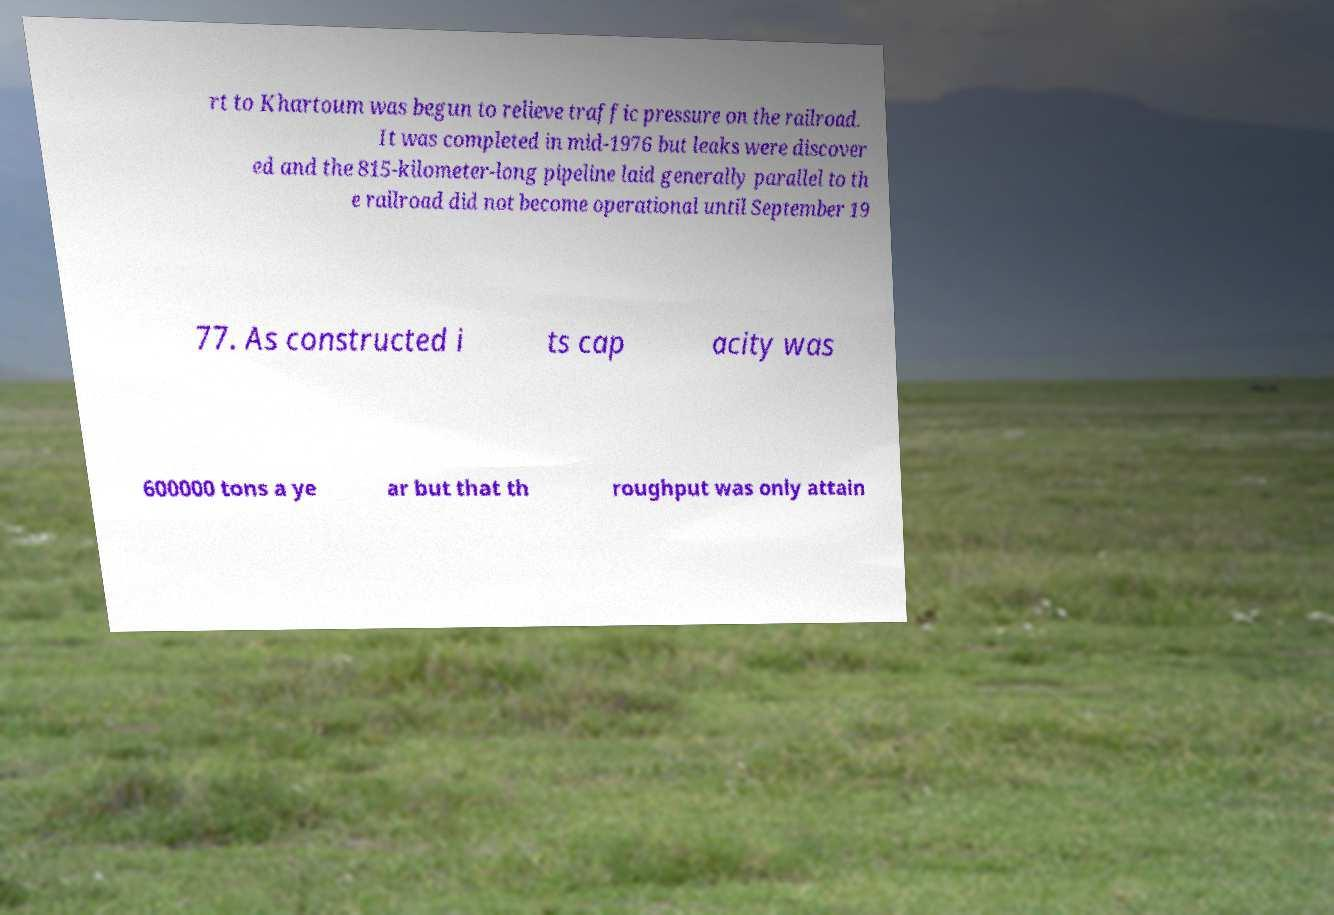There's text embedded in this image that I need extracted. Can you transcribe it verbatim? rt to Khartoum was begun to relieve traffic pressure on the railroad. It was completed in mid-1976 but leaks were discover ed and the 815-kilometer-long pipeline laid generally parallel to th e railroad did not become operational until September 19 77. As constructed i ts cap acity was 600000 tons a ye ar but that th roughput was only attain 